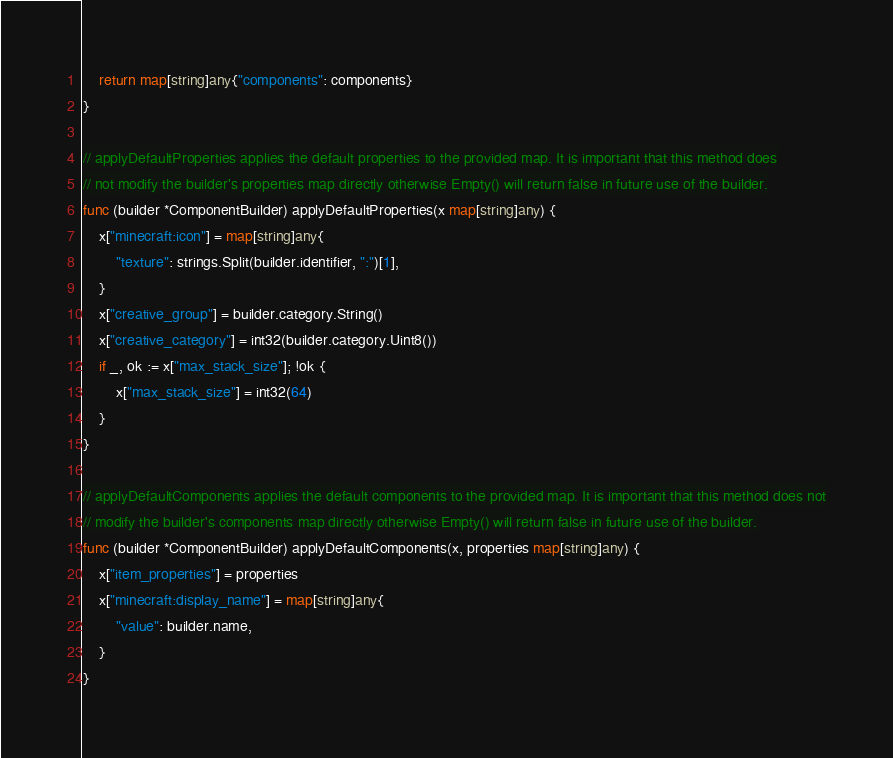Convert code to text. <code><loc_0><loc_0><loc_500><loc_500><_Go_>	return map[string]any{"components": components}
}

// applyDefaultProperties applies the default properties to the provided map. It is important that this method does
// not modify the builder's properties map directly otherwise Empty() will return false in future use of the builder.
func (builder *ComponentBuilder) applyDefaultProperties(x map[string]any) {
	x["minecraft:icon"] = map[string]any{
		"texture": strings.Split(builder.identifier, ":")[1],
	}
	x["creative_group"] = builder.category.String()
	x["creative_category"] = int32(builder.category.Uint8())
	if _, ok := x["max_stack_size"]; !ok {
		x["max_stack_size"] = int32(64)
	}
}

// applyDefaultComponents applies the default components to the provided map. It is important that this method does not
// modify the builder's components map directly otherwise Empty() will return false in future use of the builder.
func (builder *ComponentBuilder) applyDefaultComponents(x, properties map[string]any) {
	x["item_properties"] = properties
	x["minecraft:display_name"] = map[string]any{
		"value": builder.name,
	}
}
</code> 